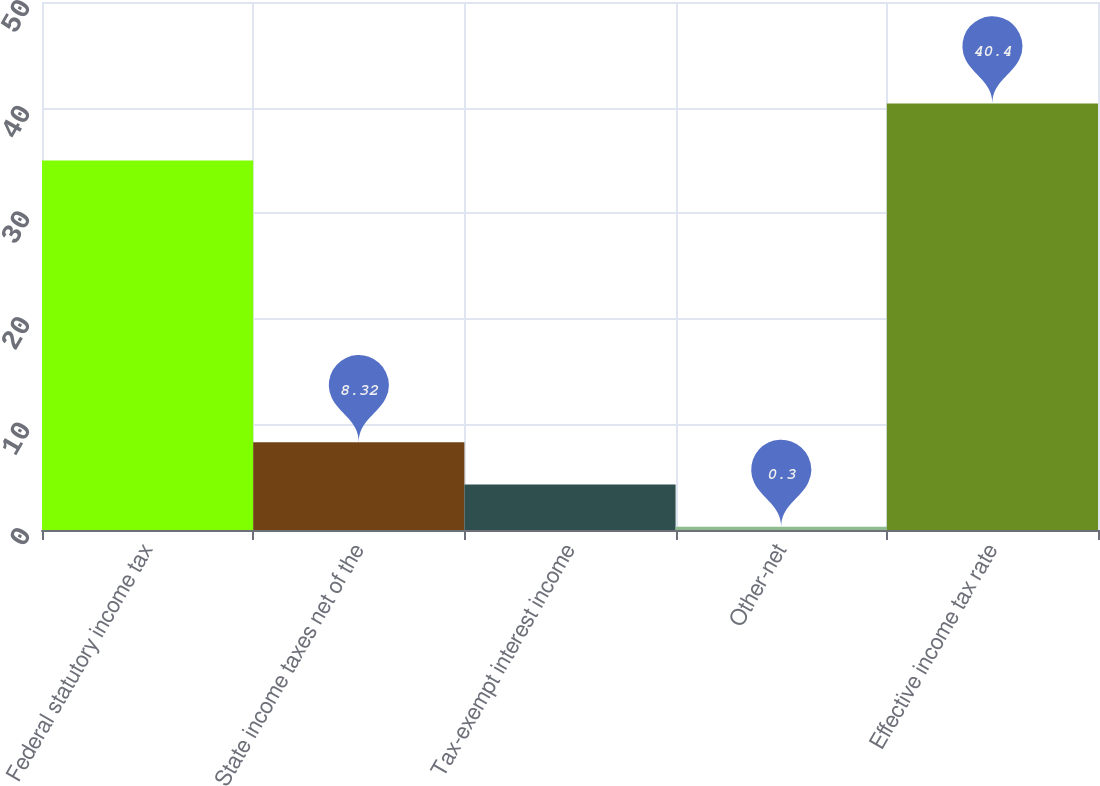Convert chart. <chart><loc_0><loc_0><loc_500><loc_500><bar_chart><fcel>Federal statutory income tax<fcel>State income taxes net of the<fcel>Tax-exempt interest income<fcel>Other-net<fcel>Effective income tax rate<nl><fcel>35<fcel>8.32<fcel>4.31<fcel>0.3<fcel>40.4<nl></chart> 